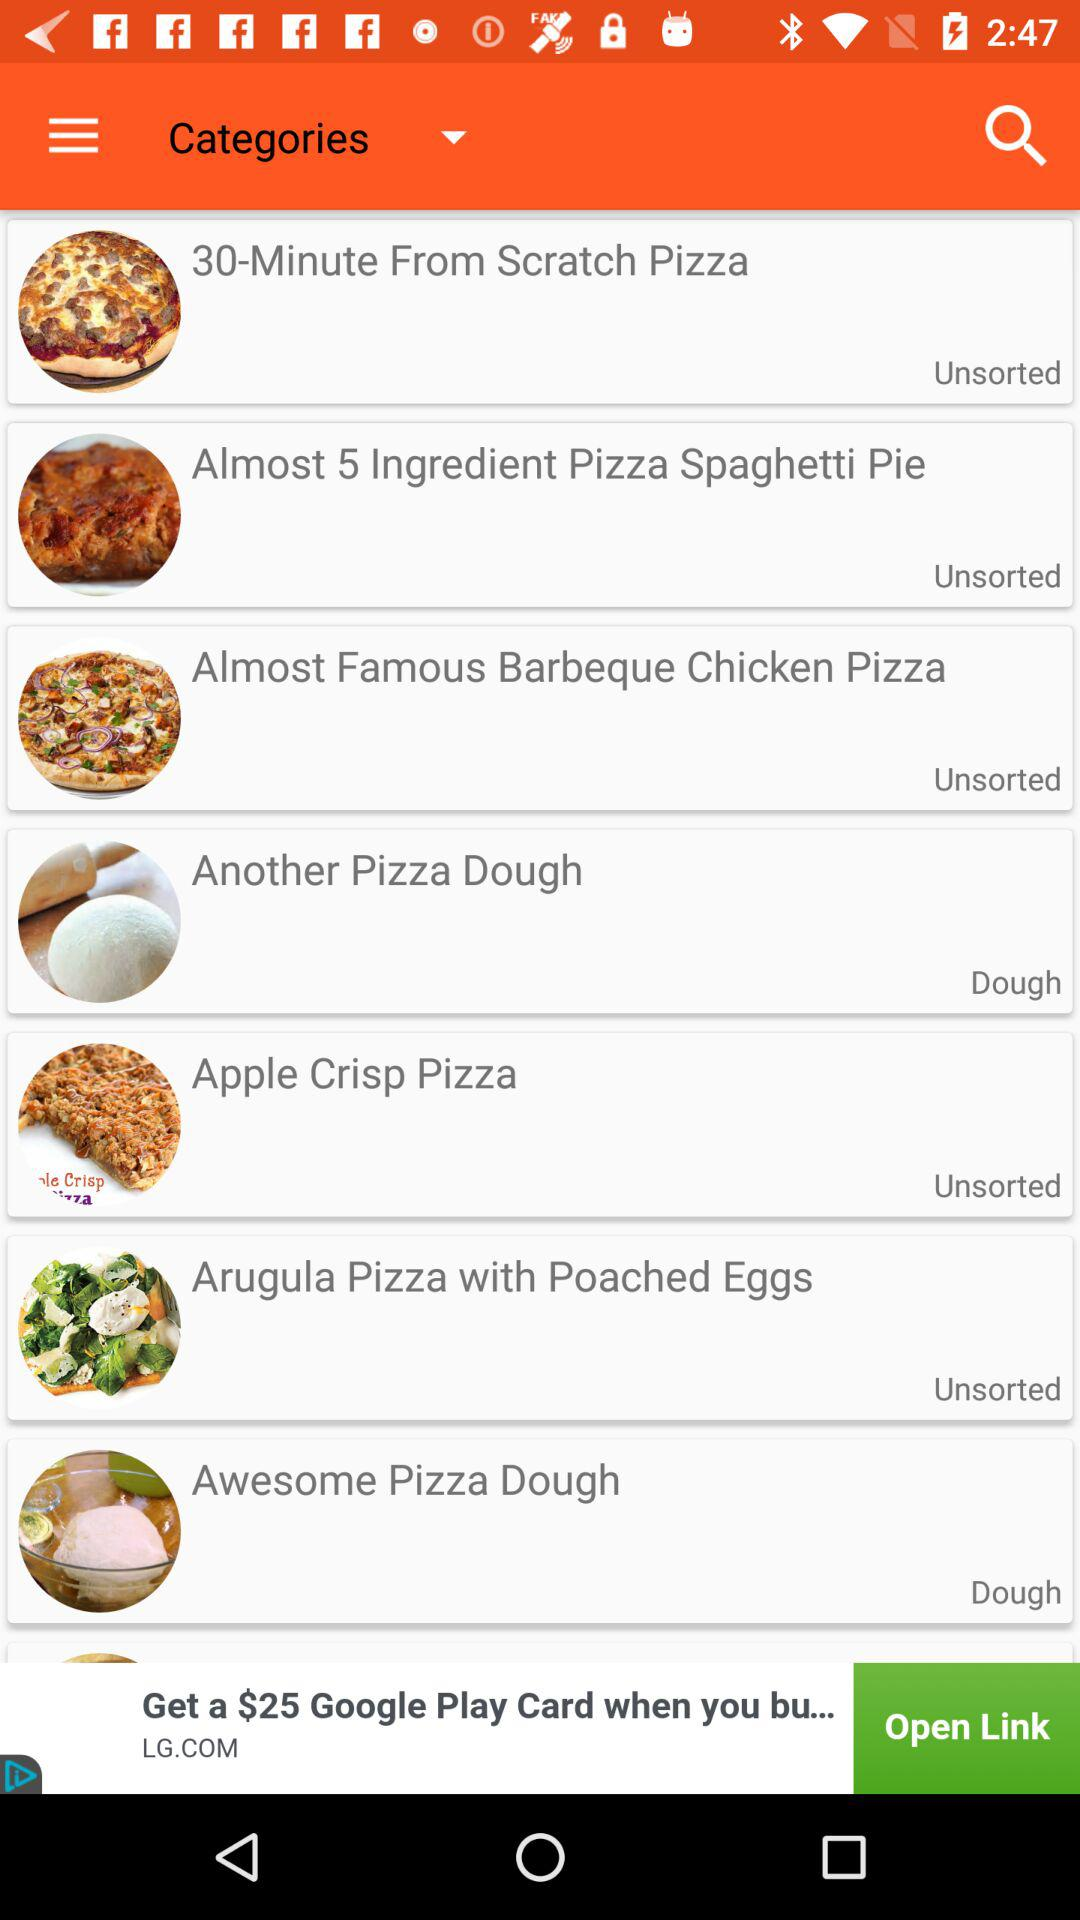What is the category of "30-Minute From Scratch Pizza"? The category is "Unsorted". 